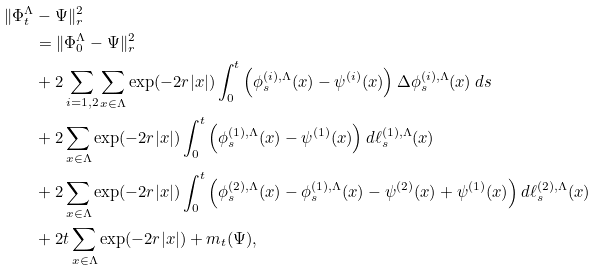<formula> <loc_0><loc_0><loc_500><loc_500>\| \Phi _ { t } ^ { \Lambda } & - \Psi \| _ { r } ^ { 2 } \\ & = \| \Phi _ { 0 } ^ { \Lambda } - \Psi \| _ { r } ^ { 2 } \\ & + 2 \sum _ { i = 1 , 2 } \sum _ { x \in \Lambda } \exp ( - 2 r | x | ) \int _ { 0 } ^ { t } \left ( \phi _ { s } ^ { ( i ) , \Lambda } ( x ) - \psi ^ { ( i ) } ( x ) \right ) \Delta \phi _ { s } ^ { ( i ) , \Lambda } ( x ) \, d s \\ & + 2 \sum _ { x \in \Lambda } \exp ( - 2 r | x | ) \int _ { 0 } ^ { t } \left ( \phi _ { s } ^ { ( 1 ) , \Lambda } ( x ) - \psi ^ { ( 1 ) } ( x ) \right ) d \ell _ { s } ^ { ( 1 ) , \Lambda } ( x ) \\ & + 2 \sum _ { x \in \Lambda } \exp ( - 2 r | x | ) \int _ { 0 } ^ { t } \left ( \phi _ { s } ^ { ( 2 ) , \Lambda } ( x ) - \phi _ { s } ^ { ( 1 ) , \Lambda } ( x ) - \psi ^ { ( 2 ) } ( x ) + \psi ^ { ( 1 ) } ( x ) \right ) d \ell _ { s } ^ { ( 2 ) , \Lambda } ( x ) \\ & + 2 t \sum _ { x \in \Lambda } \exp ( - 2 r | x | ) + m _ { t } ( \Psi ) ,</formula> 